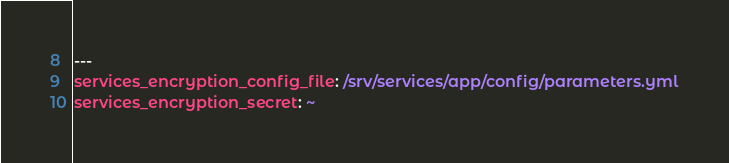<code> <loc_0><loc_0><loc_500><loc_500><_YAML_>---
services_encryption_config_file: /srv/services/app/config/parameters.yml
services_encryption_secret: ~
</code> 